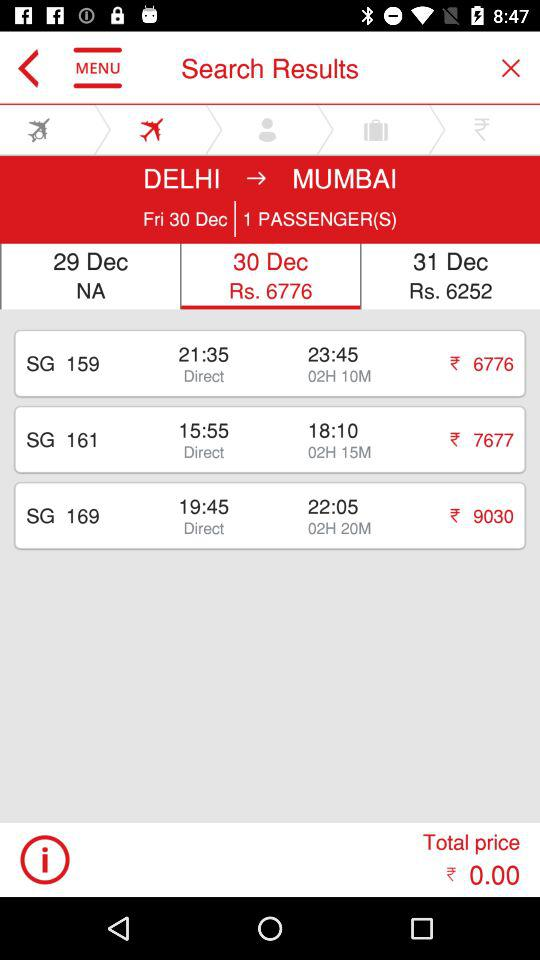What is the selected date? The selected date is December 30. 